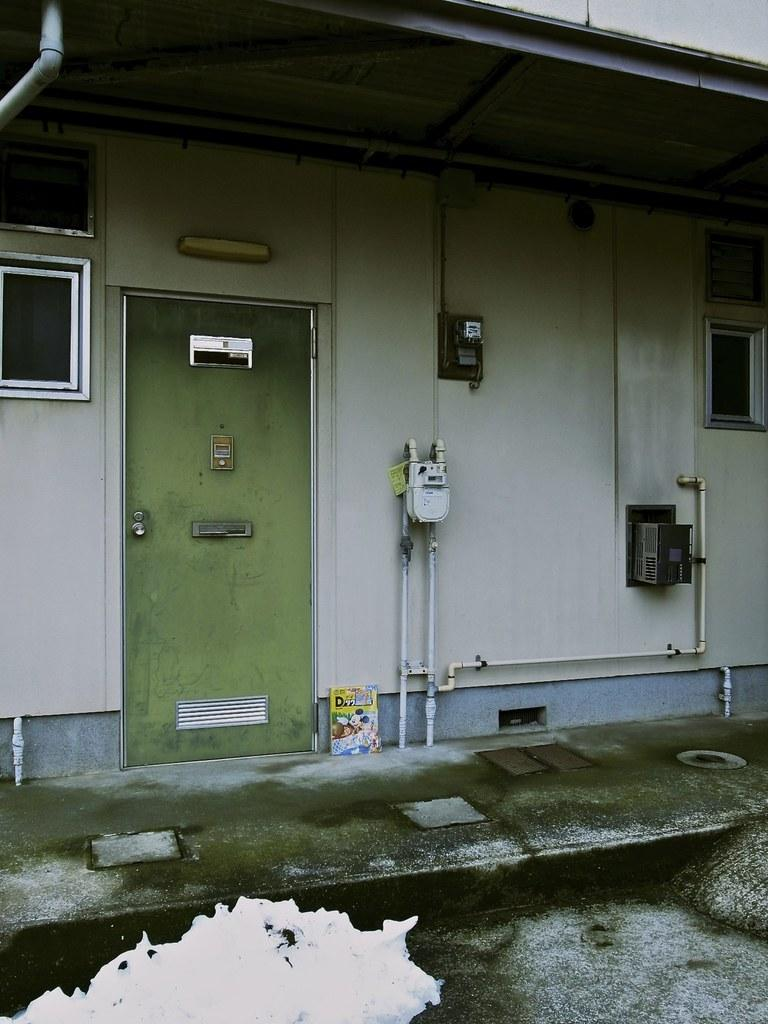What type of structure is in the image? There is a building in the image. What color is the door of the building? The door of the building is green. How many windows are visible on either side of the building? There are two windows on either side of the image. What grade of salt is recommended for use in the building? There is no information about salt or its grade in the image, as it focuses on the building and its features. 